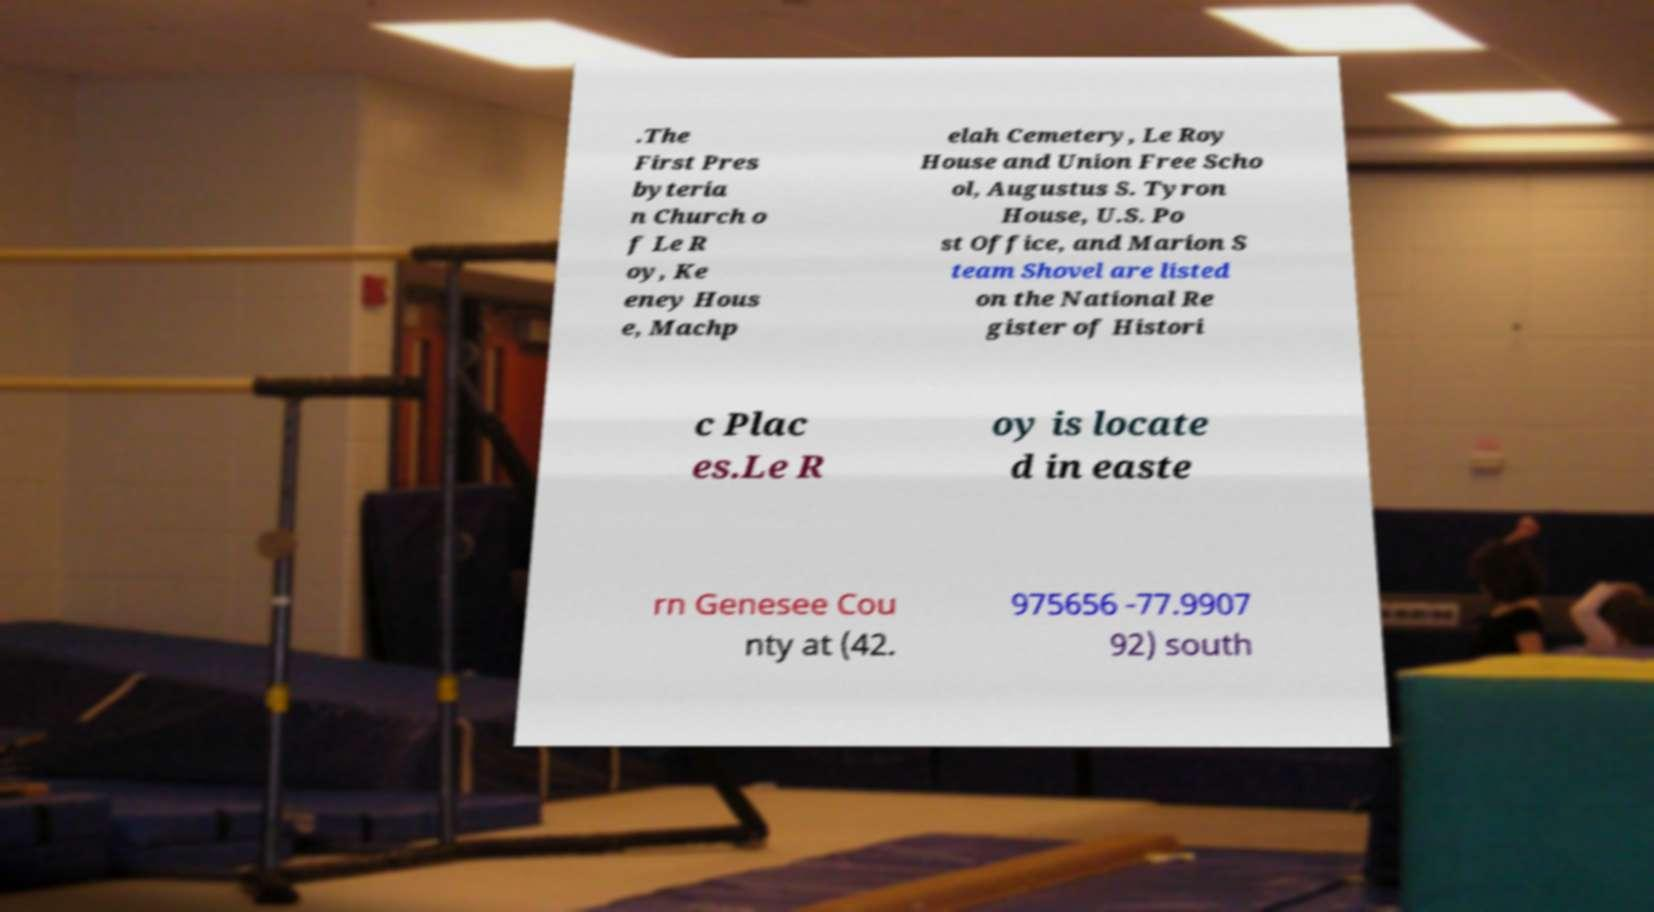I need the written content from this picture converted into text. Can you do that? .The First Pres byteria n Church o f Le R oy, Ke eney Hous e, Machp elah Cemetery, Le Roy House and Union Free Scho ol, Augustus S. Tyron House, U.S. Po st Office, and Marion S team Shovel are listed on the National Re gister of Histori c Plac es.Le R oy is locate d in easte rn Genesee Cou nty at (42. 975656 -77.9907 92) south 